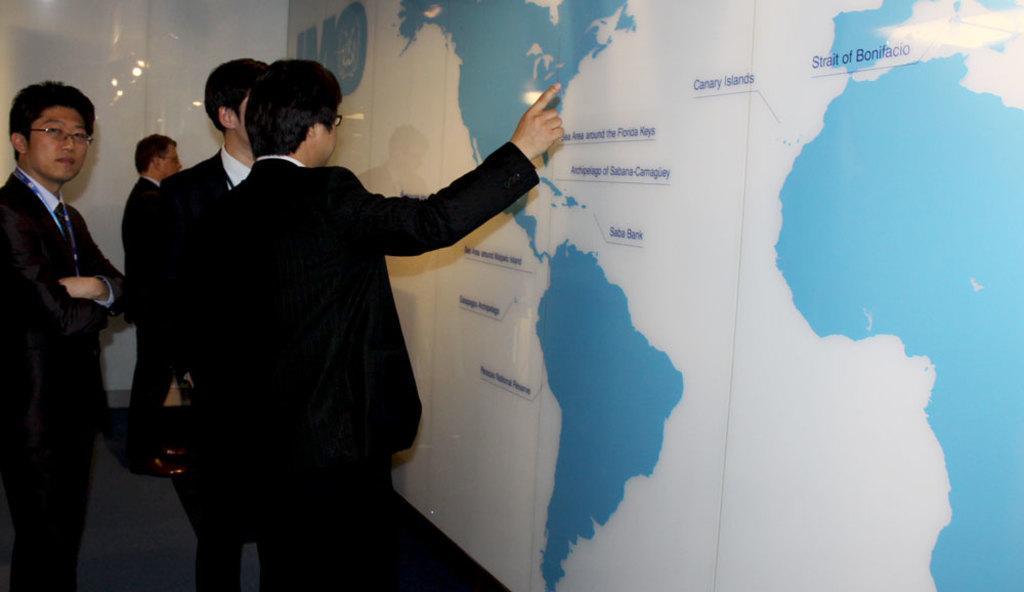How would you summarize this image in a sentence or two? In this picture we can see four persons wearing a black color coat and discussing something and pointing a hand on the banner. On the right side we can see white and blue color map banner. 